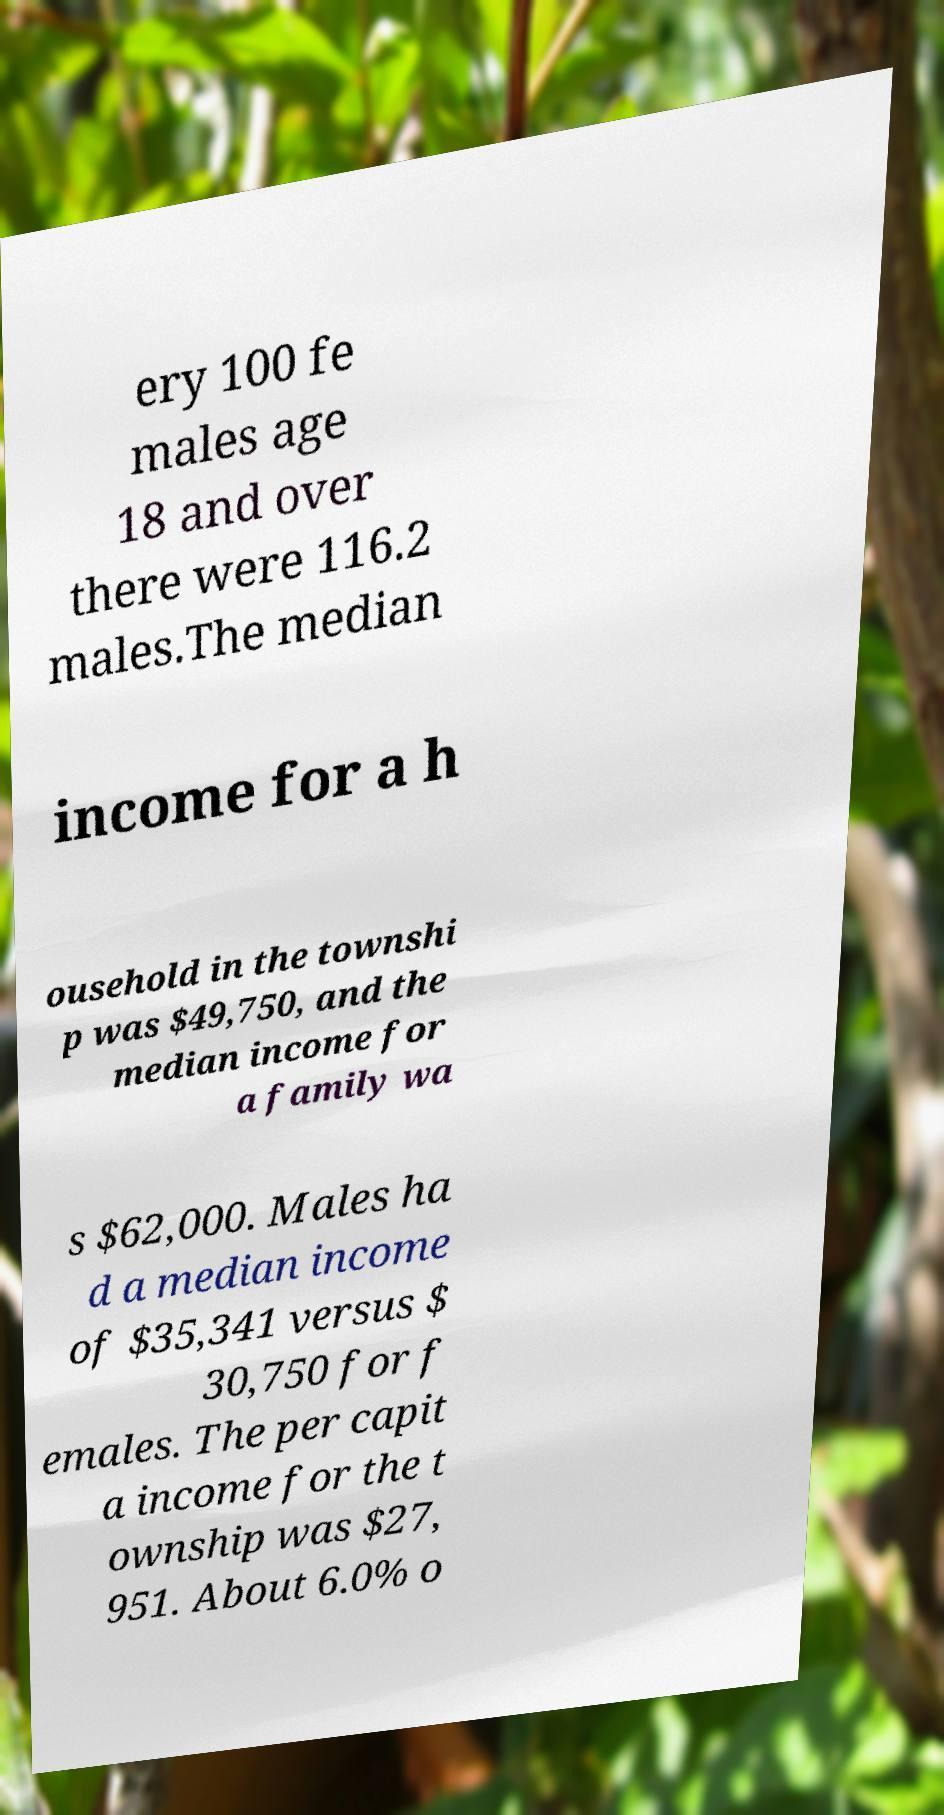Can you accurately transcribe the text from the provided image for me? ery 100 fe males age 18 and over there were 116.2 males.The median income for a h ousehold in the townshi p was $49,750, and the median income for a family wa s $62,000. Males ha d a median income of $35,341 versus $ 30,750 for f emales. The per capit a income for the t ownship was $27, 951. About 6.0% o 